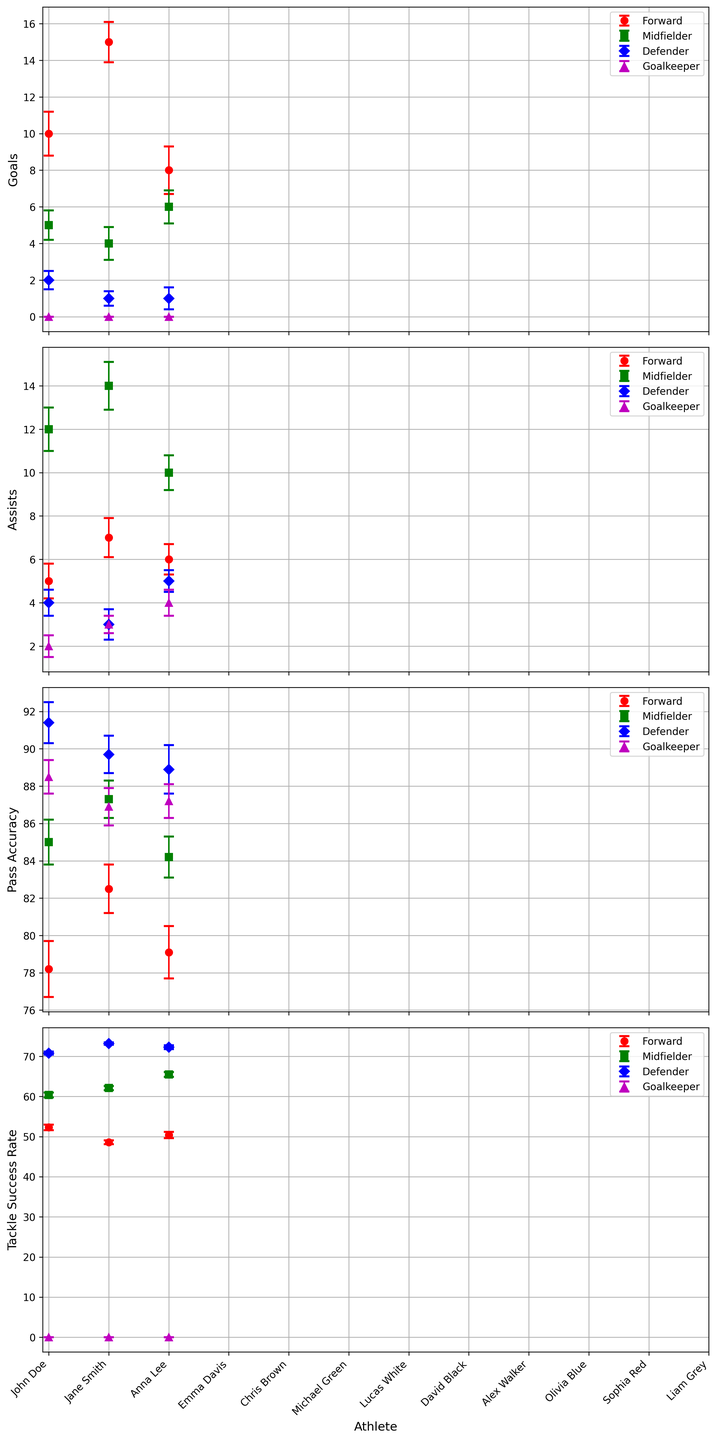What's the average number of goals scored by the Forwards? Identify the 'Goals' data points for the Forward position (John Doe: 10, Jane Smith: 15, Alex Walker: 8). Sum these values to get 33. Divide by the number of forwards (3), resulting in an average of 33/3 = 11.
Answer: 11 Which athlete has the highest Pass Accuracy among the Defenders? Look at the Pass Accuracy for each Defender (Chris Brown: 91.4, Michael Green: 89.7, Sophia Red: 88.9). Chris Brown has the highest at 91.4.
Answer: Chris Brown What is the difference in Tackle Success Rate between Anna Lee and Emma Davis? Anna Lee has a Tackle Success Rate of 60.4, and Emma Davis has 62.1. The difference is 62.1 - 60.4 = 1.7.
Answer: 1.7 Which position shows the highest error in Goals? Check the error bars for Goals across each position. Forwards have the highest individual error values (John Doe: 1.2, Jane Smith: 1.1, Alex Walker: 1.3). Alex Walker has the highest error at 1.3.
Answer: Forward (Alex Walker: 1.3) How many Midfielders have a Pass Accuracy above 85? Look at the Pass Accuracy for each Midfielder (Anna Lee: 85.0, Emma Davis: 87.3, Olivia Blue: 84.2). Two Midfielders (Anna Lee and Emma Davis) have a Pass Accuracy above 85.
Answer: 2 Which athlete has the lowest number of Assists? Check the Assists for each athlete and find the lowest value. Chris Brown has 4 assists which is the lowest among all athletes.
Answer: Chris Brown What is the combined number of Games Played for the Defenders? Sum the 'Games Played' for all Defenders (Chris Brown: 20, Michael Green: 19, Sophia Red: 18). The total is 20 + 19 + 18 = 57.
Answer: 57 Who has the highest Pass Accuracy among all athletes? Look through the Pass Accuracy data points for each athlete. Chris Brown has the highest at 91.4.
Answer: Chris Brown Is Emma Davis's Pass Accuracy higher than Lucas White's? Emma Davis has a Pass Accuracy of 87.3 while Lucas White has 88.5. Comparing these, Lucas White's Pass Accuracy is higher.
Answer: No 